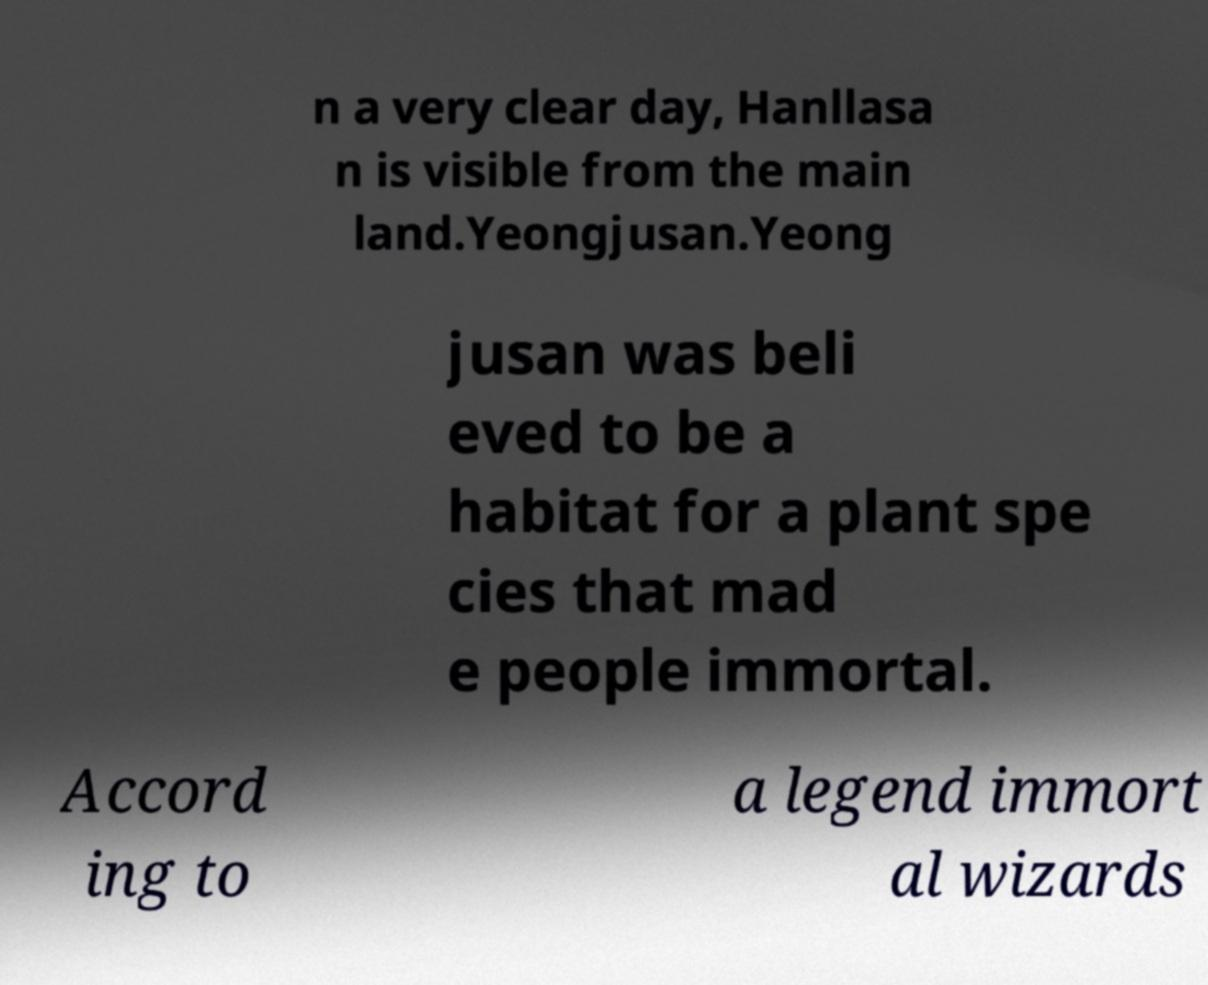There's text embedded in this image that I need extracted. Can you transcribe it verbatim? n a very clear day, Hanllasa n is visible from the main land.Yeongjusan.Yeong jusan was beli eved to be a habitat for a plant spe cies that mad e people immortal. Accord ing to a legend immort al wizards 